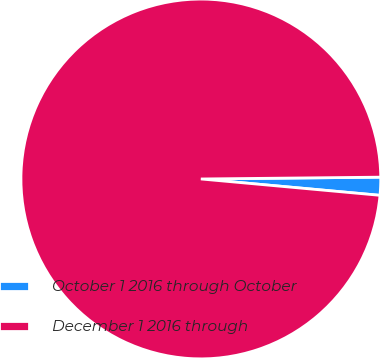Convert chart. <chart><loc_0><loc_0><loc_500><loc_500><pie_chart><fcel>October 1 2016 through October<fcel>December 1 2016 through<nl><fcel>1.61%<fcel>98.39%<nl></chart> 